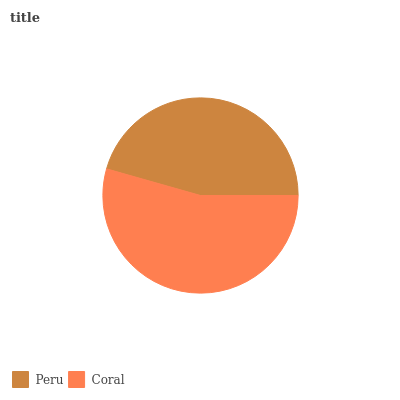Is Peru the minimum?
Answer yes or no. Yes. Is Coral the maximum?
Answer yes or no. Yes. Is Coral the minimum?
Answer yes or no. No. Is Coral greater than Peru?
Answer yes or no. Yes. Is Peru less than Coral?
Answer yes or no. Yes. Is Peru greater than Coral?
Answer yes or no. No. Is Coral less than Peru?
Answer yes or no. No. Is Coral the high median?
Answer yes or no. Yes. Is Peru the low median?
Answer yes or no. Yes. Is Peru the high median?
Answer yes or no. No. Is Coral the low median?
Answer yes or no. No. 